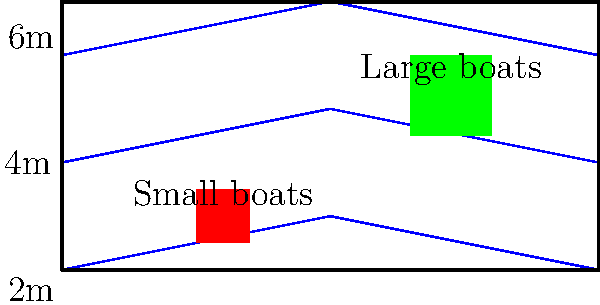As an urban designer specializing in waterfront development, you are tasked with optimizing the layout of a marina. Given the water depth contours shown in the diagram and two types of boats (small and large), what is the most efficient arrangement for maximizing boat capacity while ensuring safety? To optimize the marina layout, we need to consider the following factors:

1. Water depth requirements:
   - Small boats typically require less depth (e.g., 2-3m)
   - Large boats need deeper water (e.g., 4-6m)

2. Safety considerations:
   - Boats should have sufficient depth to avoid grounding
   - A safety margin should be maintained between the boat's draft and the water depth

3. Capacity maximization:
   - Utilize available space efficiently
   - Place boats in appropriate depth zones

Step-by-step approach:

1. Analyze the depth contours:
   - Shallow zone (0-40m from shore): 2-4m depth
   - Middle zone (40-80m from shore): 4-6m depth
   - Deep zone (80-100m from shore): 6m+ depth

2. Allocate boat types:
   - Small boats: Place in the shallow zone (0-40m from shore)
   - Large boats: Place in the middle and deep zones (40-100m from shore)

3. Optimize layout:
   - Arrange small boats in rows parallel to the shore in the shallow zone
   - Position large boats perpendicular to the shore in the middle and deep zones
   - Leave navigation channels between boat rows for safe maneuvering

4. Maximize capacity:
   - Use the entire width of the marina for small boats in the shallow zone
   - Utilize the longer length of the marina for large boats in deeper water

5. Ensure safety:
   - Maintain a 1m safety margin between boat draft and water depth
   - Implement proper mooring systems for each boat size

By following this approach, we can create an efficient marina layout that maximizes capacity while ensuring the safety of all boats based on their size and the available water depth.
Answer: Place small boats parallel to shore in 2-4m depth zone; large boats perpendicular to shore in 4-6m+ depth zones. 